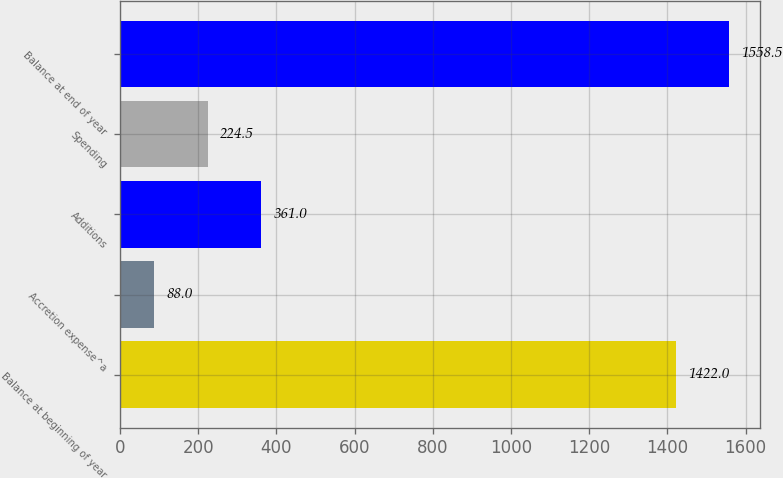Convert chart to OTSL. <chart><loc_0><loc_0><loc_500><loc_500><bar_chart><fcel>Balance at beginning of year<fcel>Accretion expense^a<fcel>Additions<fcel>Spending<fcel>Balance at end of year<nl><fcel>1422<fcel>88<fcel>361<fcel>224.5<fcel>1558.5<nl></chart> 